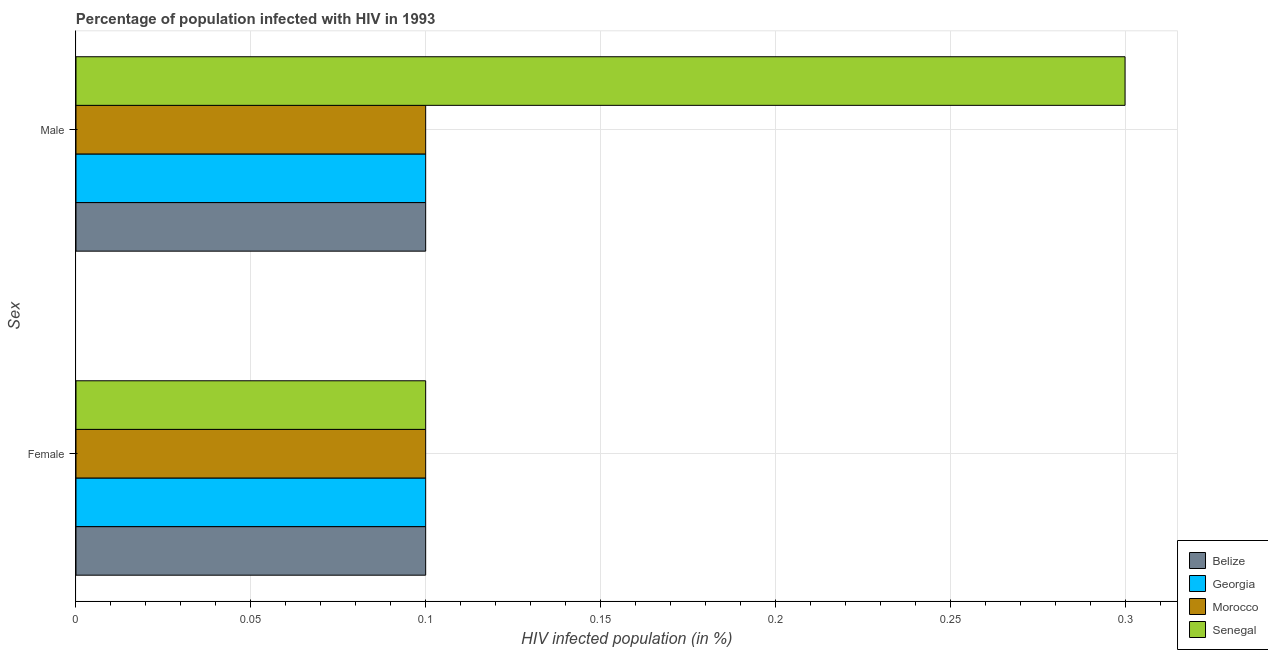Are the number of bars per tick equal to the number of legend labels?
Ensure brevity in your answer.  Yes. What is the label of the 2nd group of bars from the top?
Your answer should be compact. Female. Across all countries, what is the maximum percentage of females who are infected with hiv?
Your answer should be very brief. 0.1. In which country was the percentage of females who are infected with hiv maximum?
Your answer should be very brief. Belize. In which country was the percentage of males who are infected with hiv minimum?
Your answer should be very brief. Belize. What is the total percentage of males who are infected with hiv in the graph?
Your answer should be very brief. 0.6. What is the difference between the percentage of males who are infected with hiv in Georgia and the percentage of females who are infected with hiv in Morocco?
Provide a short and direct response. 0. What is the average percentage of males who are infected with hiv per country?
Make the answer very short. 0.15. What is the difference between the percentage of males who are infected with hiv and percentage of females who are infected with hiv in Senegal?
Your answer should be very brief. 0.2. What is the ratio of the percentage of males who are infected with hiv in Georgia to that in Belize?
Offer a terse response. 1. What does the 4th bar from the top in Female represents?
Ensure brevity in your answer.  Belize. What does the 1st bar from the bottom in Male represents?
Your response must be concise. Belize. How many countries are there in the graph?
Keep it short and to the point. 4. What is the difference between two consecutive major ticks on the X-axis?
Keep it short and to the point. 0.05. Does the graph contain any zero values?
Give a very brief answer. No. How many legend labels are there?
Provide a short and direct response. 4. How are the legend labels stacked?
Ensure brevity in your answer.  Vertical. What is the title of the graph?
Offer a very short reply. Percentage of population infected with HIV in 1993. What is the label or title of the X-axis?
Provide a succinct answer. HIV infected population (in %). What is the label or title of the Y-axis?
Offer a terse response. Sex. What is the HIV infected population (in %) of Belize in Female?
Offer a very short reply. 0.1. What is the HIV infected population (in %) of Georgia in Female?
Your answer should be compact. 0.1. What is the HIV infected population (in %) of Belize in Male?
Ensure brevity in your answer.  0.1. Across all Sex, what is the maximum HIV infected population (in %) in Belize?
Make the answer very short. 0.1. Across all Sex, what is the maximum HIV infected population (in %) of Georgia?
Offer a terse response. 0.1. Across all Sex, what is the maximum HIV infected population (in %) in Morocco?
Make the answer very short. 0.1. Across all Sex, what is the minimum HIV infected population (in %) of Morocco?
Keep it short and to the point. 0.1. What is the total HIV infected population (in %) of Belize in the graph?
Offer a very short reply. 0.2. What is the total HIV infected population (in %) of Georgia in the graph?
Give a very brief answer. 0.2. What is the difference between the HIV infected population (in %) in Georgia in Female and that in Male?
Provide a short and direct response. 0. What is the difference between the HIV infected population (in %) in Morocco in Female and that in Male?
Offer a terse response. 0. What is the difference between the HIV infected population (in %) of Belize in Female and the HIV infected population (in %) of Georgia in Male?
Offer a very short reply. 0. What is the difference between the HIV infected population (in %) in Belize in Female and the HIV infected population (in %) in Morocco in Male?
Your answer should be very brief. 0. What is the difference between the HIV infected population (in %) in Belize in Female and the HIV infected population (in %) in Senegal in Male?
Provide a succinct answer. -0.2. What is the difference between the HIV infected population (in %) in Morocco in Female and the HIV infected population (in %) in Senegal in Male?
Give a very brief answer. -0.2. What is the average HIV infected population (in %) in Belize per Sex?
Your answer should be compact. 0.1. What is the average HIV infected population (in %) of Georgia per Sex?
Your answer should be very brief. 0.1. What is the average HIV infected population (in %) in Senegal per Sex?
Make the answer very short. 0.2. What is the difference between the HIV infected population (in %) in Belize and HIV infected population (in %) in Morocco in Female?
Keep it short and to the point. 0. What is the difference between the HIV infected population (in %) of Belize and HIV infected population (in %) of Senegal in Female?
Offer a terse response. 0. What is the difference between the HIV infected population (in %) of Morocco and HIV infected population (in %) of Senegal in Female?
Keep it short and to the point. 0. What is the difference between the HIV infected population (in %) of Belize and HIV infected population (in %) of Georgia in Male?
Make the answer very short. 0. What is the difference between the HIV infected population (in %) in Belize and HIV infected population (in %) in Morocco in Male?
Provide a succinct answer. 0. What is the difference between the HIV infected population (in %) of Georgia and HIV infected population (in %) of Senegal in Male?
Keep it short and to the point. -0.2. What is the ratio of the HIV infected population (in %) of Belize in Female to that in Male?
Offer a very short reply. 1. What is the ratio of the HIV infected population (in %) in Georgia in Female to that in Male?
Your response must be concise. 1. What is the ratio of the HIV infected population (in %) in Morocco in Female to that in Male?
Your answer should be compact. 1. What is the difference between the highest and the second highest HIV infected population (in %) of Morocco?
Give a very brief answer. 0. What is the difference between the highest and the second highest HIV infected population (in %) of Senegal?
Ensure brevity in your answer.  0.2. What is the difference between the highest and the lowest HIV infected population (in %) in Belize?
Provide a short and direct response. 0. What is the difference between the highest and the lowest HIV infected population (in %) of Morocco?
Offer a very short reply. 0. 